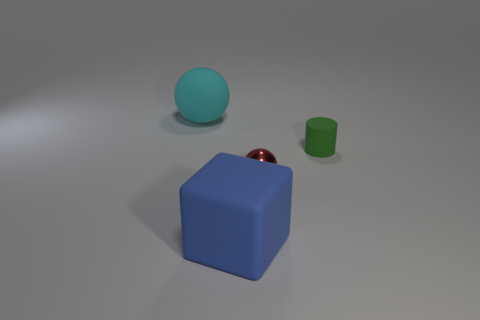Add 2 large objects. How many objects exist? 6 Subtract all cylinders. How many objects are left? 3 Add 1 small yellow metal objects. How many small yellow metal objects exist? 1 Subtract 0 blue cylinders. How many objects are left? 4 Subtract all tiny spheres. Subtract all tiny green metal objects. How many objects are left? 3 Add 1 blue rubber objects. How many blue rubber objects are left? 2 